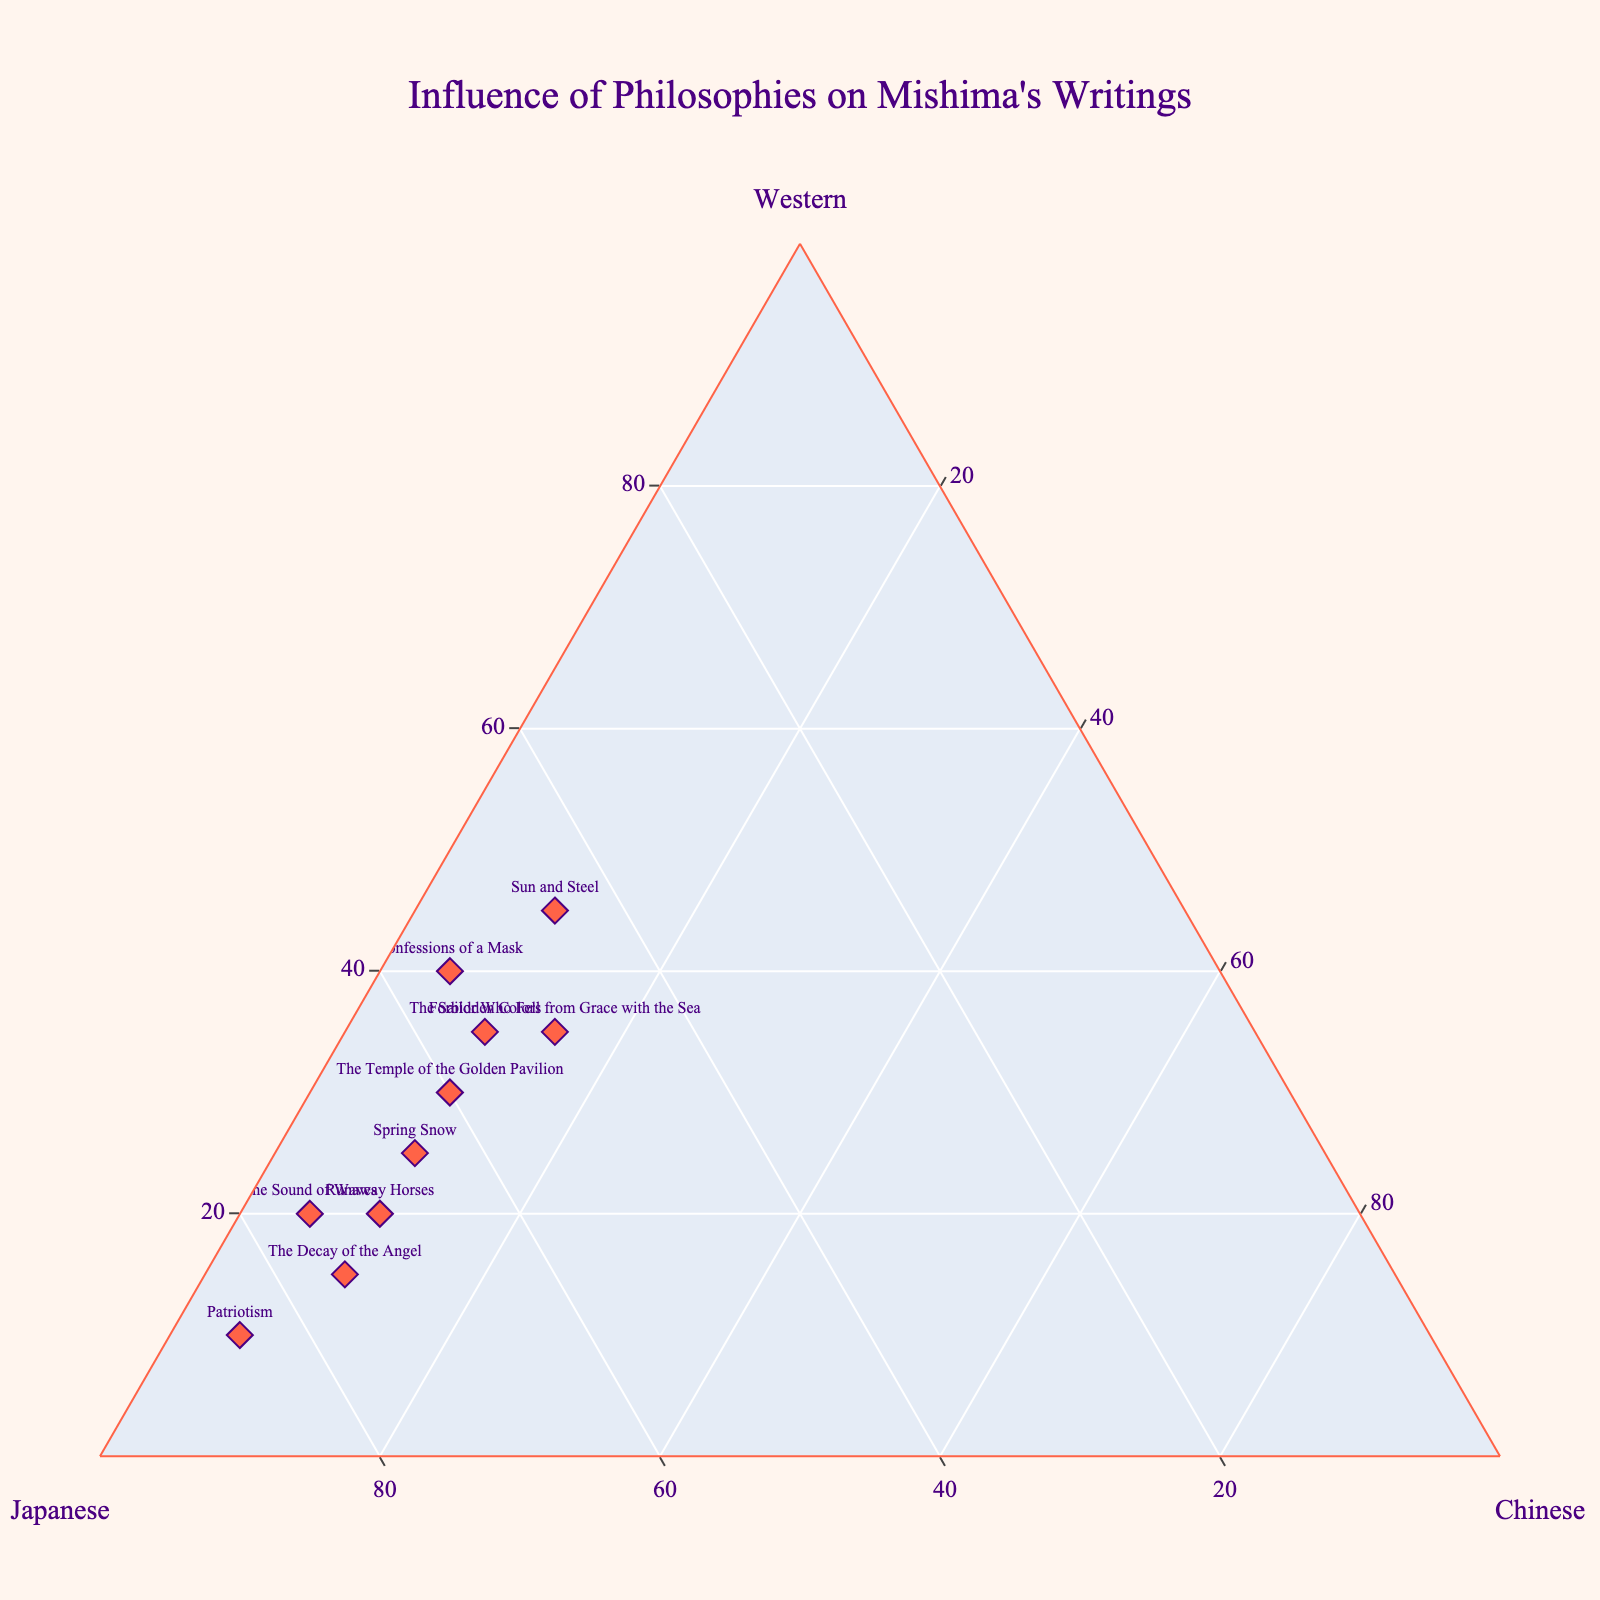What's the title of the plot? The plot's title is usually displayed at the top of the figure. In this case, the title is "Influence of Philosophies on Mishima's Writings," clearly indicating what the plot represents.
Answer: Influence of Philosophies on Mishima's Writings How many works of Mishima are visualized in the plot? The number of data points, each representing a work of Mishima, can be counted from the figure. By counting the labeled points, we find there are 10 works visualized.
Answer: 10 Which work shows the highest influence of Japanese philosophy? By looking at the point positioned closest to the 'Japanese' axis (relative to the 100% mark), we can identify the work. "Patriotism" has the highest value, at 85%.
Answer: Patriotism Which work shows the least influence of Chinese philosophy? The point closest to the 'Chinese' end of the ternary plot, where the value is the smallest, represents the work with the least influence of Chinese philosophy. "Confessions of a Mask" shows only 5% influence of Chinese philosophy.
Answer: Confessions of a Mask How many works have exactly 10% influence from Chinese philosophy? By checking the ternary plot, we count the data points that have the 'Chinese' percentage at 10%. There are 6 works: The Temple of the Golden Pavilion, Spring Snow, Runaway Horses, The Decay of the Angel, Sun and Steel, and Forbidden Colors.
Answer: 6 Which work balances Western and Japanese influences equally? By finding the point where the 'Western' and 'Japanese' values are equal, we identify "Sun and Steel" as having both influences at 45%.
Answer: Sun and Steel Which work has the highest Western influence? The points closer to the 'Western' axis maximum indicate higher influence. "Sun and Steel" has the highest influence of 45%.
Answer: Sun and Steel Compare the Western influence on "Confessions of a Mask" and "Forbidden Colors." Which one is higher? By examining the values, "Confessions of a Mask" has 40% Western influence, while "Forbidden Colors" has 35%. Hence, "Confessions of a Mask" has higher Western influence.
Answer: Confessions of a Mask What is the average Japanese influence across all works? Summing the Japanese influences and dividing by the number of works gives the average. (60 + 55 + 50 + 65 + 70 + 75 + 45 + 85 + 75 + 55) / 10 = 63.5%.
Answer: 63.5% Which work is the closest to having an equal balance of Western, Japanese, and Chinese influences? The point near the center of the ternary plot indicates a balance. "Sun and Steel" is the closest with values of 45% Western, 45% Japanese, and 10% Chinese.
Answer: Sun and Steel 